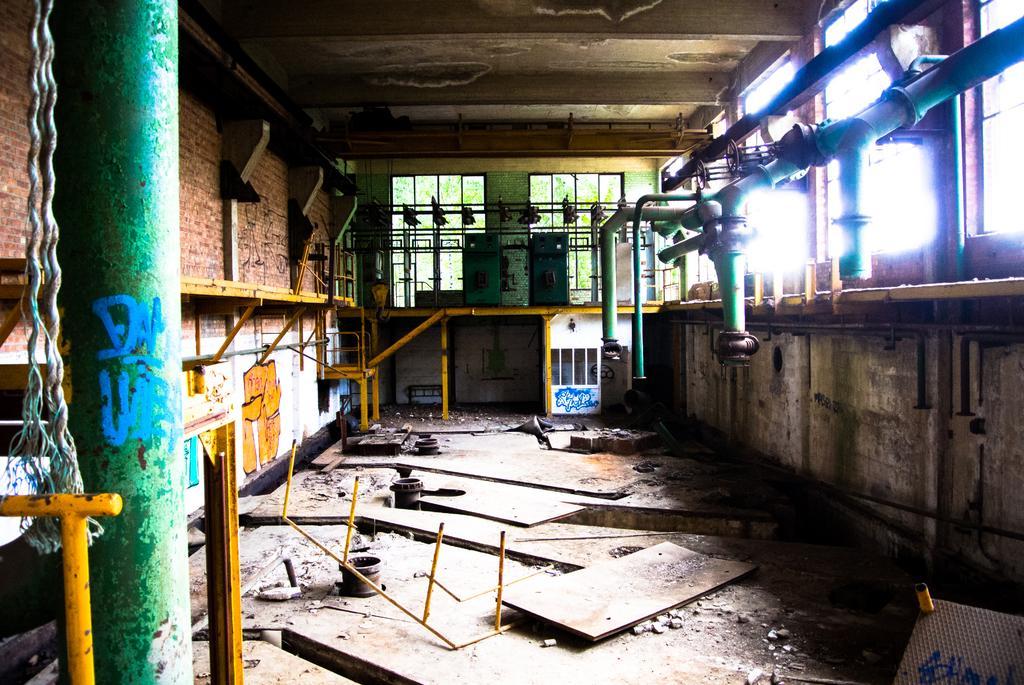In one or two sentences, can you explain what this image depicts? This picture is clicked inside the hall. In the foreground we can see the wooden objects and metal objects are lying on the ground. On the left we can see a rope and a metal rod. On the right we can see the metal pipes and we can see the metal rods and many other objects. In the background we can see the windows and through the windows we can see the trees and we can see some other objects. At the top there is a roof. 